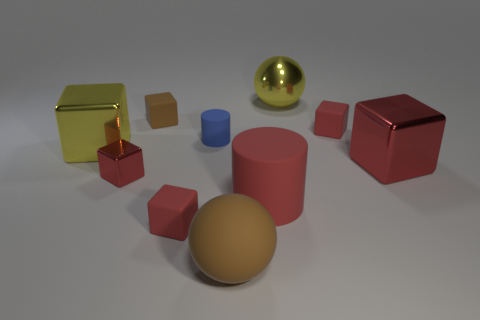There is a red thing that is both on the left side of the blue matte cylinder and to the right of the tiny red metal block; what shape is it?
Your answer should be very brief. Cube. There is a large cylinder that is made of the same material as the small brown cube; what is its color?
Provide a succinct answer. Red. Is the number of yellow shiny cubes that are on the right side of the small metallic cube the same as the number of large brown matte cubes?
Ensure brevity in your answer.  Yes. What is the shape of the brown object that is the same size as the blue rubber cylinder?
Your response must be concise. Cube. How many other things are there of the same shape as the big brown matte thing?
Your answer should be compact. 1. There is a brown rubber cube; does it have the same size as the red block behind the large red shiny cube?
Make the answer very short. Yes. How many objects are things on the left side of the big brown sphere or tiny red matte things?
Your answer should be very brief. 6. What is the shape of the tiny rubber thing right of the red rubber cylinder?
Your answer should be compact. Cube. Are there the same number of small red metal things that are right of the big metal sphere and yellow metallic things that are to the left of the large rubber cylinder?
Keep it short and to the point. No. What color is the tiny matte cube that is behind the big red cylinder and left of the yellow sphere?
Your response must be concise. Brown. 